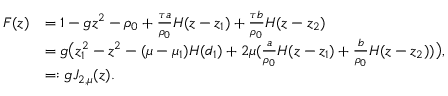Convert formula to latex. <formula><loc_0><loc_0><loc_500><loc_500>\begin{array} { r l } { F ( z ) } & { = 1 - g z ^ { 2 } - \rho _ { 0 } + \frac { \tau a } { \rho _ { 0 } } H ( z - z _ { 1 } ) + \frac { \tau b } { \rho _ { 0 } } H ( z - z _ { 2 } ) } \\ & { = g \left ( z _ { 1 } ^ { 2 } - z ^ { 2 } - ( \mu - \mu _ { 1 } ) H ( d _ { 1 } ) + 2 \mu ( \frac { a } { \rho _ { 0 } } H ( z - z _ { 1 } ) + \frac { b } { \rho _ { 0 } } H ( z - z _ { 2 } ) ) \right ) , } \\ & { = \colon g J _ { 2 , \mu } ( z ) . } \end{array}</formula> 